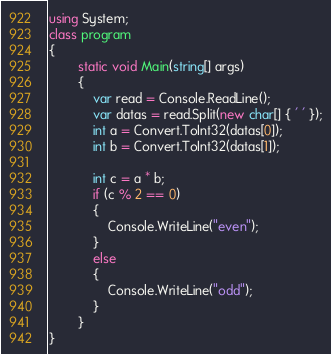Convert code to text. <code><loc_0><loc_0><loc_500><loc_500><_C#_>using System;
class program
{
		static void Main(string[] args)
        {
            var read = Console.ReadLine();
            var datas = read.Split(new char[] { ' ' });
            int a = Convert.ToInt32(datas[0]);
            int b = Convert.ToInt32(datas[1]);

            int c = a * b;
            if (c % 2 == 0)
            {
                Console.WriteLine("even");
            }
            else
            {
                Console.WriteLine("odd");
            }
        }
}</code> 